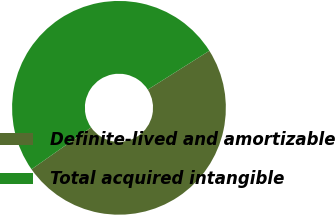Convert chart to OTSL. <chart><loc_0><loc_0><loc_500><loc_500><pie_chart><fcel>Definite-lived and amortizable<fcel>Total acquired intangible<nl><fcel>49.21%<fcel>50.79%<nl></chart> 